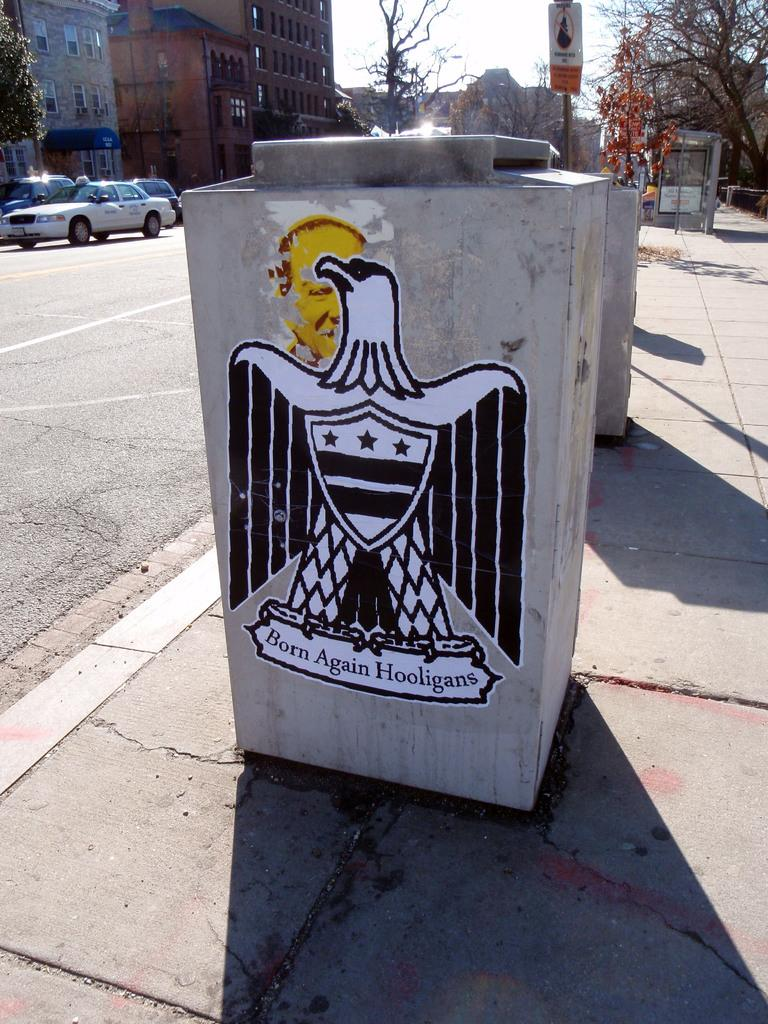<image>
Present a compact description of the photo's key features. A cement block has an eagle drawing and says Born Again Hooligans on it. 